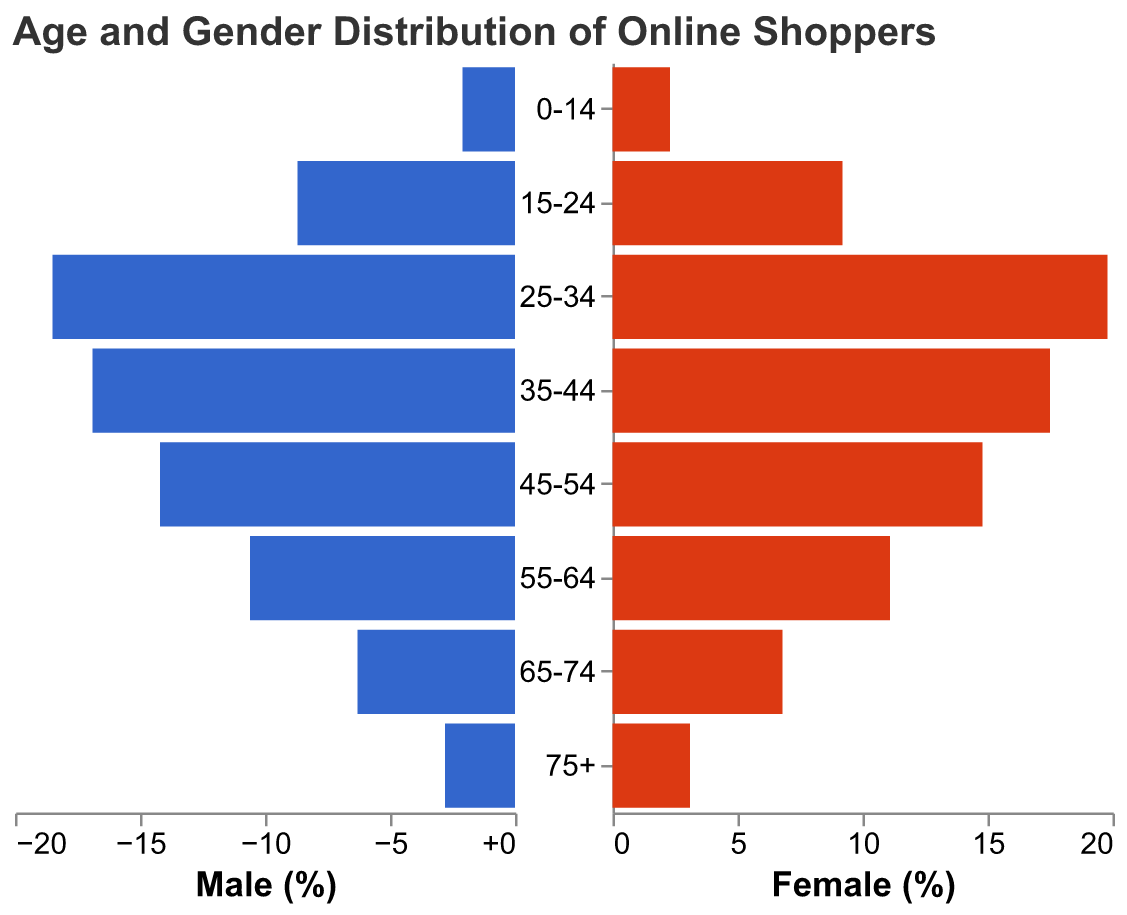What is the title of the figure? The title of the figure is typically located at the top and provides a brief description of what the figure represents. In this case, it reads "Age and Gender Distribution of Online Shoppers".
Answer: Age and Gender Distribution of Online Shoppers What age group has the highest percentage of female online shoppers? By looking at the bars representing females, the tallest bar corresponds to the age group of 25-34, indicating the highest percentage.
Answer: 25-34 Which gender has a higher percentage in the age group 55-64? Compare the lengths of the bars for males and females in the 55-64 age group. The bar for females is slightly longer, indicating a higher percentage.
Answer: Female What is the percentage difference between male and female shoppers in the 25-34 age group? The percentage of male shoppers is 18.5% and for females, it is 19.8%. The difference is calculated as 19.8 - 18.5 = 1.3.
Answer: 1.3% Which age group has the smallest percentage of male shoppers? The smallest bar for males corresponds to the 0-14 age group.
Answer: 0-14 Is there an age group where the percentage of male and female shoppers is equal? By examining the lengths of the bars for both genders in each age group, it is clear that no age group has equal percentages for males and females.
Answer: No How many age groups have more than 10% of female shoppers? Count the number of age groups where the female bars exceed the 10% mark. The age groups are 15-24, 25-34, 35-44, 45-54, and 55-64.
Answer: 5 Which age group has the largest disparity in percentages between male and female shoppers? To find the largest disparity, calculate the absolute differences in percentages for each age group and compare them. The largest difference is in the 25-34 age group:
Answer: 25-34 